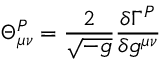Convert formula to latex. <formula><loc_0><loc_0><loc_500><loc_500>\Theta _ { \mu \nu } ^ { P } = \frac { 2 } { \sqrt { - g } } \frac { \delta \Gamma ^ { P } } { \delta g ^ { \mu \nu } }</formula> 